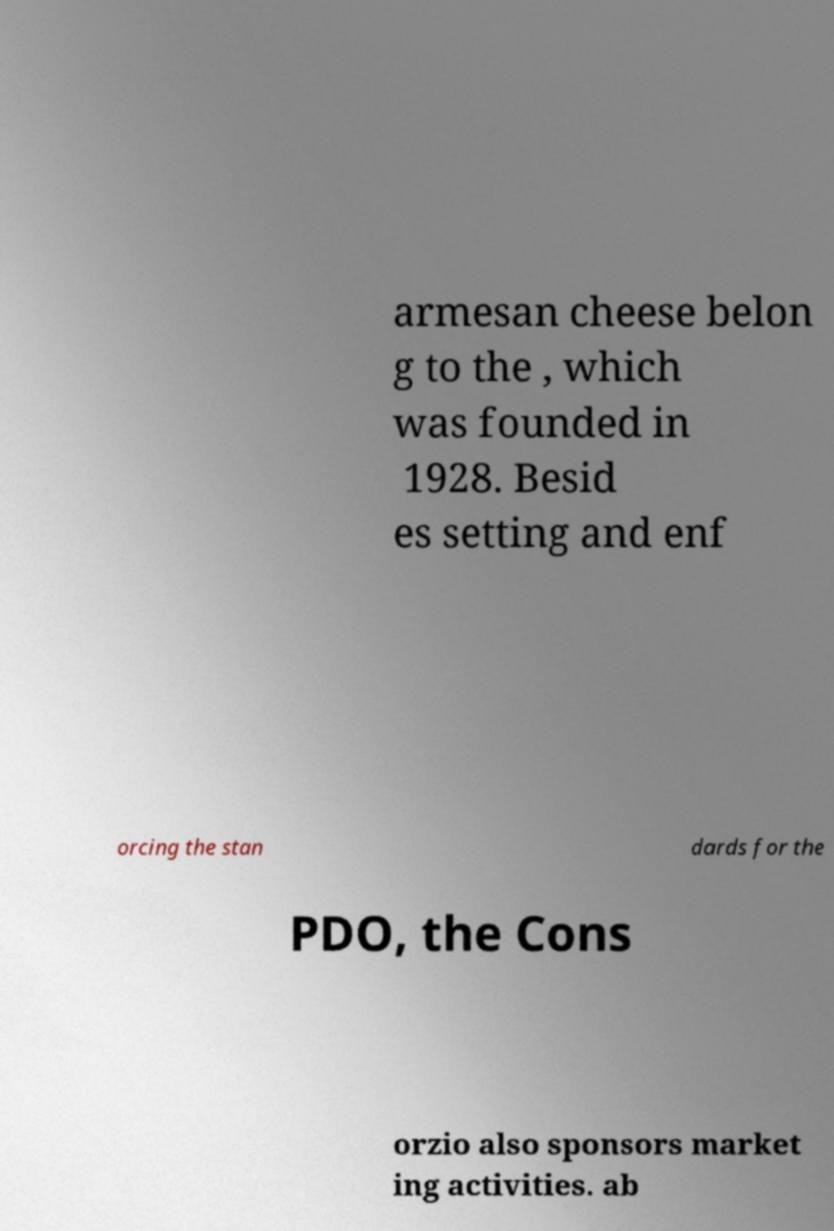Could you extract and type out the text from this image? armesan cheese belon g to the , which was founded in 1928. Besid es setting and enf orcing the stan dards for the PDO, the Cons orzio also sponsors market ing activities. ab 